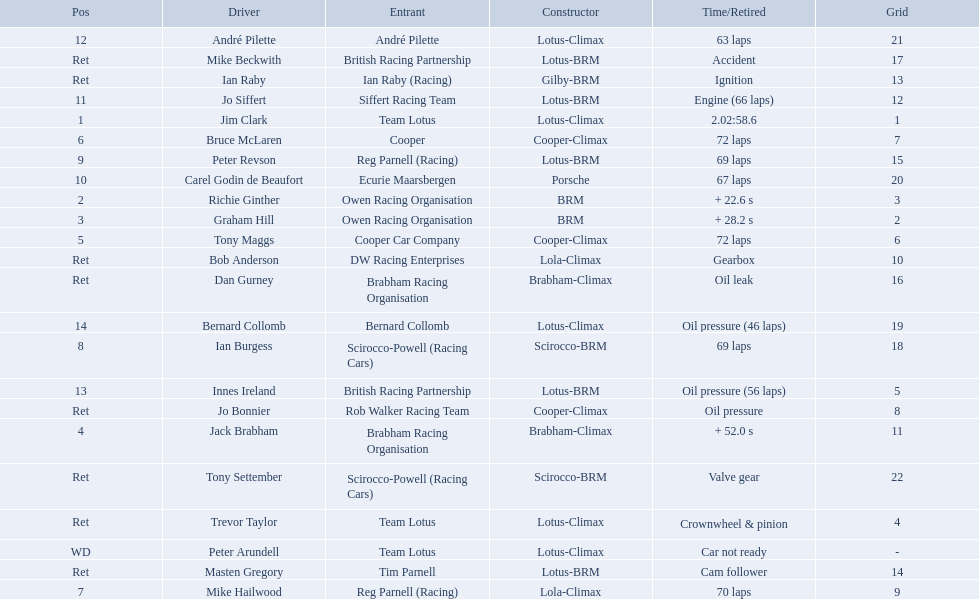Who drove in the 1963 international gold cup? Jim Clark, Richie Ginther, Graham Hill, Jack Brabham, Tony Maggs, Bruce McLaren, Mike Hailwood, Ian Burgess, Peter Revson, Carel Godin de Beaufort, Jo Siffert, André Pilette, Innes Ireland, Bernard Collomb, Ian Raby, Dan Gurney, Mike Beckwith, Masten Gregory, Trevor Taylor, Jo Bonnier, Tony Settember, Bob Anderson, Peter Arundell. Who had problems during the race? Jo Siffert, Innes Ireland, Bernard Collomb, Ian Raby, Dan Gurney, Mike Beckwith, Masten Gregory, Trevor Taylor, Jo Bonnier, Tony Settember, Bob Anderson, Peter Arundell. Of those who was still able to finish the race? Jo Siffert, Innes Ireland, Bernard Collomb. Of those who faced the same issue? Innes Ireland, Bernard Collomb. What issue did they have? Oil pressure. Who were the two that that a similar problem? Innes Ireland. What was their common problem? Oil pressure. Who are all the drivers? Jim Clark, Richie Ginther, Graham Hill, Jack Brabham, Tony Maggs, Bruce McLaren, Mike Hailwood, Ian Burgess, Peter Revson, Carel Godin de Beaufort, Jo Siffert, André Pilette, Innes Ireland, Bernard Collomb, Ian Raby, Dan Gurney, Mike Beckwith, Masten Gregory, Trevor Taylor, Jo Bonnier, Tony Settember, Bob Anderson, Peter Arundell. What were their positions? 1, 2, 3, 4, 5, 6, 7, 8, 9, 10, 11, 12, 13, 14, Ret, Ret, Ret, Ret, Ret, Ret, Ret, Ret, WD. What are all the constructor names? Lotus-Climax, BRM, BRM, Brabham-Climax, Cooper-Climax, Cooper-Climax, Lola-Climax, Scirocco-BRM, Lotus-BRM, Porsche, Lotus-BRM, Lotus-Climax, Lotus-BRM, Lotus-Climax, Gilby-BRM, Brabham-Climax, Lotus-BRM, Lotus-BRM, Lotus-Climax, Cooper-Climax, Scirocco-BRM, Lola-Climax, Lotus-Climax. And which drivers drove a cooper-climax? Tony Maggs, Bruce McLaren. Between those tow, who was positioned higher? Tony Maggs. 